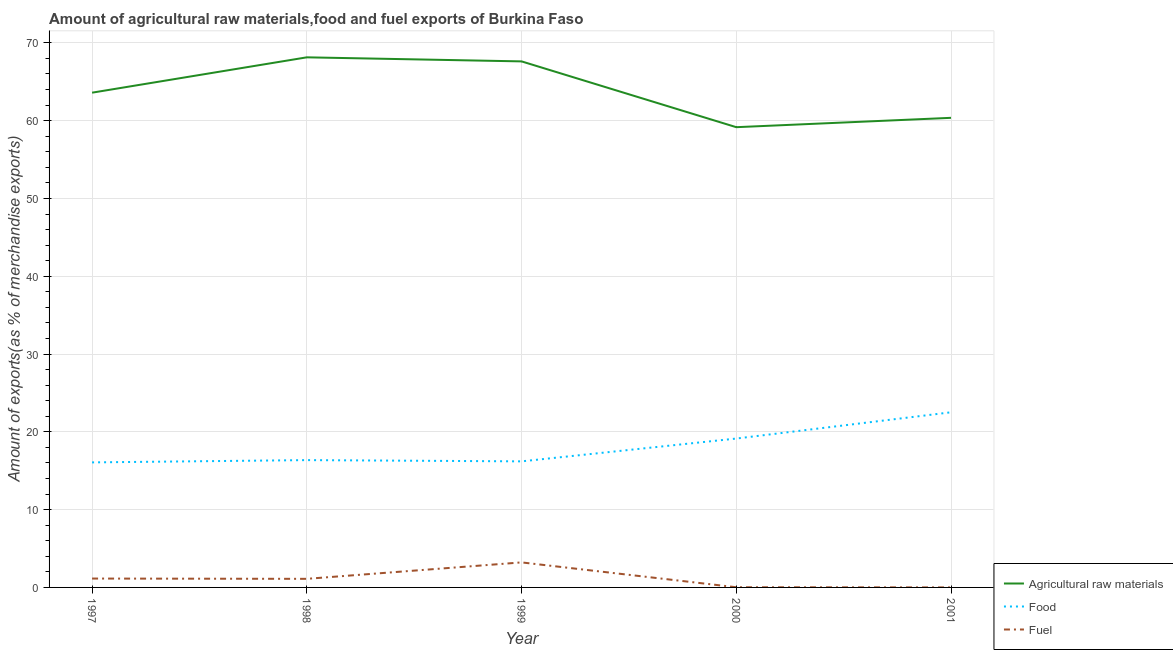What is the percentage of fuel exports in 2000?
Provide a succinct answer. 0.02. Across all years, what is the maximum percentage of fuel exports?
Offer a very short reply. 3.22. Across all years, what is the minimum percentage of food exports?
Provide a short and direct response. 16.07. In which year was the percentage of food exports maximum?
Your answer should be very brief. 2001. What is the total percentage of food exports in the graph?
Your response must be concise. 90.3. What is the difference between the percentage of fuel exports in 1998 and that in 2001?
Offer a very short reply. 1.1. What is the difference between the percentage of fuel exports in 1999 and the percentage of raw materials exports in 1998?
Make the answer very short. -64.92. What is the average percentage of food exports per year?
Offer a very short reply. 18.06. In the year 1997, what is the difference between the percentage of fuel exports and percentage of raw materials exports?
Your response must be concise. -62.46. What is the ratio of the percentage of food exports in 1998 to that in 2000?
Keep it short and to the point. 0.86. What is the difference between the highest and the second highest percentage of food exports?
Keep it short and to the point. 3.37. What is the difference between the highest and the lowest percentage of food exports?
Your response must be concise. 6.44. In how many years, is the percentage of food exports greater than the average percentage of food exports taken over all years?
Provide a succinct answer. 2. Is it the case that in every year, the sum of the percentage of raw materials exports and percentage of food exports is greater than the percentage of fuel exports?
Make the answer very short. Yes. Does the percentage of fuel exports monotonically increase over the years?
Your answer should be very brief. No. Is the percentage of fuel exports strictly greater than the percentage of food exports over the years?
Offer a terse response. No. What is the difference between two consecutive major ticks on the Y-axis?
Your response must be concise. 10. Does the graph contain grids?
Your answer should be very brief. Yes. Where does the legend appear in the graph?
Give a very brief answer. Bottom right. How many legend labels are there?
Provide a succinct answer. 3. What is the title of the graph?
Provide a succinct answer. Amount of agricultural raw materials,food and fuel exports of Burkina Faso. Does "Taxes on income" appear as one of the legend labels in the graph?
Give a very brief answer. No. What is the label or title of the X-axis?
Provide a short and direct response. Year. What is the label or title of the Y-axis?
Offer a very short reply. Amount of exports(as % of merchandise exports). What is the Amount of exports(as % of merchandise exports) in Agricultural raw materials in 1997?
Make the answer very short. 63.6. What is the Amount of exports(as % of merchandise exports) of Food in 1997?
Make the answer very short. 16.07. What is the Amount of exports(as % of merchandise exports) of Fuel in 1997?
Keep it short and to the point. 1.14. What is the Amount of exports(as % of merchandise exports) of Agricultural raw materials in 1998?
Provide a short and direct response. 68.14. What is the Amount of exports(as % of merchandise exports) of Food in 1998?
Offer a very short reply. 16.37. What is the Amount of exports(as % of merchandise exports) of Fuel in 1998?
Keep it short and to the point. 1.1. What is the Amount of exports(as % of merchandise exports) of Agricultural raw materials in 1999?
Provide a short and direct response. 67.62. What is the Amount of exports(as % of merchandise exports) of Food in 1999?
Make the answer very short. 16.2. What is the Amount of exports(as % of merchandise exports) in Fuel in 1999?
Your response must be concise. 3.22. What is the Amount of exports(as % of merchandise exports) of Agricultural raw materials in 2000?
Offer a terse response. 59.16. What is the Amount of exports(as % of merchandise exports) of Food in 2000?
Offer a very short reply. 19.14. What is the Amount of exports(as % of merchandise exports) of Fuel in 2000?
Give a very brief answer. 0.02. What is the Amount of exports(as % of merchandise exports) in Agricultural raw materials in 2001?
Make the answer very short. 60.36. What is the Amount of exports(as % of merchandise exports) of Food in 2001?
Give a very brief answer. 22.51. What is the Amount of exports(as % of merchandise exports) in Fuel in 2001?
Provide a short and direct response. 0. Across all years, what is the maximum Amount of exports(as % of merchandise exports) in Agricultural raw materials?
Offer a very short reply. 68.14. Across all years, what is the maximum Amount of exports(as % of merchandise exports) in Food?
Give a very brief answer. 22.51. Across all years, what is the maximum Amount of exports(as % of merchandise exports) of Fuel?
Your answer should be compact. 3.22. Across all years, what is the minimum Amount of exports(as % of merchandise exports) of Agricultural raw materials?
Your answer should be very brief. 59.16. Across all years, what is the minimum Amount of exports(as % of merchandise exports) of Food?
Offer a very short reply. 16.07. Across all years, what is the minimum Amount of exports(as % of merchandise exports) in Fuel?
Keep it short and to the point. 0. What is the total Amount of exports(as % of merchandise exports) in Agricultural raw materials in the graph?
Ensure brevity in your answer.  318.89. What is the total Amount of exports(as % of merchandise exports) of Food in the graph?
Your answer should be very brief. 90.3. What is the total Amount of exports(as % of merchandise exports) of Fuel in the graph?
Provide a short and direct response. 5.49. What is the difference between the Amount of exports(as % of merchandise exports) in Agricultural raw materials in 1997 and that in 1998?
Make the answer very short. -4.54. What is the difference between the Amount of exports(as % of merchandise exports) of Food in 1997 and that in 1998?
Provide a succinct answer. -0.29. What is the difference between the Amount of exports(as % of merchandise exports) in Fuel in 1997 and that in 1998?
Offer a very short reply. 0.04. What is the difference between the Amount of exports(as % of merchandise exports) of Agricultural raw materials in 1997 and that in 1999?
Provide a succinct answer. -4.02. What is the difference between the Amount of exports(as % of merchandise exports) of Food in 1997 and that in 1999?
Your answer should be compact. -0.13. What is the difference between the Amount of exports(as % of merchandise exports) of Fuel in 1997 and that in 1999?
Your response must be concise. -2.08. What is the difference between the Amount of exports(as % of merchandise exports) in Agricultural raw materials in 1997 and that in 2000?
Your answer should be very brief. 4.44. What is the difference between the Amount of exports(as % of merchandise exports) in Food in 1997 and that in 2000?
Keep it short and to the point. -3.07. What is the difference between the Amount of exports(as % of merchandise exports) of Fuel in 1997 and that in 2000?
Provide a short and direct response. 1.12. What is the difference between the Amount of exports(as % of merchandise exports) in Agricultural raw materials in 1997 and that in 2001?
Give a very brief answer. 3.23. What is the difference between the Amount of exports(as % of merchandise exports) in Food in 1997 and that in 2001?
Your answer should be compact. -6.44. What is the difference between the Amount of exports(as % of merchandise exports) of Fuel in 1997 and that in 2001?
Your response must be concise. 1.14. What is the difference between the Amount of exports(as % of merchandise exports) of Agricultural raw materials in 1998 and that in 1999?
Your answer should be compact. 0.52. What is the difference between the Amount of exports(as % of merchandise exports) in Food in 1998 and that in 1999?
Give a very brief answer. 0.16. What is the difference between the Amount of exports(as % of merchandise exports) in Fuel in 1998 and that in 1999?
Keep it short and to the point. -2.11. What is the difference between the Amount of exports(as % of merchandise exports) of Agricultural raw materials in 1998 and that in 2000?
Your answer should be very brief. 8.98. What is the difference between the Amount of exports(as % of merchandise exports) of Food in 1998 and that in 2000?
Offer a terse response. -2.77. What is the difference between the Amount of exports(as % of merchandise exports) of Fuel in 1998 and that in 2000?
Keep it short and to the point. 1.08. What is the difference between the Amount of exports(as % of merchandise exports) in Agricultural raw materials in 1998 and that in 2001?
Make the answer very short. 7.78. What is the difference between the Amount of exports(as % of merchandise exports) in Food in 1998 and that in 2001?
Provide a succinct answer. -6.15. What is the difference between the Amount of exports(as % of merchandise exports) in Fuel in 1998 and that in 2001?
Your answer should be very brief. 1.1. What is the difference between the Amount of exports(as % of merchandise exports) of Agricultural raw materials in 1999 and that in 2000?
Your answer should be compact. 8.46. What is the difference between the Amount of exports(as % of merchandise exports) in Food in 1999 and that in 2000?
Give a very brief answer. -2.93. What is the difference between the Amount of exports(as % of merchandise exports) in Fuel in 1999 and that in 2000?
Make the answer very short. 3.19. What is the difference between the Amount of exports(as % of merchandise exports) in Agricultural raw materials in 1999 and that in 2001?
Give a very brief answer. 7.26. What is the difference between the Amount of exports(as % of merchandise exports) in Food in 1999 and that in 2001?
Provide a succinct answer. -6.31. What is the difference between the Amount of exports(as % of merchandise exports) in Fuel in 1999 and that in 2001?
Your response must be concise. 3.22. What is the difference between the Amount of exports(as % of merchandise exports) of Agricultural raw materials in 2000 and that in 2001?
Keep it short and to the point. -1.2. What is the difference between the Amount of exports(as % of merchandise exports) of Food in 2000 and that in 2001?
Your answer should be very brief. -3.37. What is the difference between the Amount of exports(as % of merchandise exports) in Fuel in 2000 and that in 2001?
Offer a very short reply. 0.02. What is the difference between the Amount of exports(as % of merchandise exports) in Agricultural raw materials in 1997 and the Amount of exports(as % of merchandise exports) in Food in 1998?
Your response must be concise. 47.23. What is the difference between the Amount of exports(as % of merchandise exports) in Agricultural raw materials in 1997 and the Amount of exports(as % of merchandise exports) in Fuel in 1998?
Your answer should be compact. 62.49. What is the difference between the Amount of exports(as % of merchandise exports) in Food in 1997 and the Amount of exports(as % of merchandise exports) in Fuel in 1998?
Provide a succinct answer. 14.97. What is the difference between the Amount of exports(as % of merchandise exports) of Agricultural raw materials in 1997 and the Amount of exports(as % of merchandise exports) of Food in 1999?
Keep it short and to the point. 47.39. What is the difference between the Amount of exports(as % of merchandise exports) in Agricultural raw materials in 1997 and the Amount of exports(as % of merchandise exports) in Fuel in 1999?
Offer a very short reply. 60.38. What is the difference between the Amount of exports(as % of merchandise exports) in Food in 1997 and the Amount of exports(as % of merchandise exports) in Fuel in 1999?
Your answer should be very brief. 12.86. What is the difference between the Amount of exports(as % of merchandise exports) in Agricultural raw materials in 1997 and the Amount of exports(as % of merchandise exports) in Food in 2000?
Provide a short and direct response. 44.46. What is the difference between the Amount of exports(as % of merchandise exports) in Agricultural raw materials in 1997 and the Amount of exports(as % of merchandise exports) in Fuel in 2000?
Provide a succinct answer. 63.58. What is the difference between the Amount of exports(as % of merchandise exports) in Food in 1997 and the Amount of exports(as % of merchandise exports) in Fuel in 2000?
Provide a short and direct response. 16.05. What is the difference between the Amount of exports(as % of merchandise exports) in Agricultural raw materials in 1997 and the Amount of exports(as % of merchandise exports) in Food in 2001?
Make the answer very short. 41.09. What is the difference between the Amount of exports(as % of merchandise exports) of Agricultural raw materials in 1997 and the Amount of exports(as % of merchandise exports) of Fuel in 2001?
Keep it short and to the point. 63.6. What is the difference between the Amount of exports(as % of merchandise exports) of Food in 1997 and the Amount of exports(as % of merchandise exports) of Fuel in 2001?
Your answer should be compact. 16.07. What is the difference between the Amount of exports(as % of merchandise exports) in Agricultural raw materials in 1998 and the Amount of exports(as % of merchandise exports) in Food in 1999?
Provide a short and direct response. 51.94. What is the difference between the Amount of exports(as % of merchandise exports) of Agricultural raw materials in 1998 and the Amount of exports(as % of merchandise exports) of Fuel in 1999?
Give a very brief answer. 64.92. What is the difference between the Amount of exports(as % of merchandise exports) of Food in 1998 and the Amount of exports(as % of merchandise exports) of Fuel in 1999?
Keep it short and to the point. 13.15. What is the difference between the Amount of exports(as % of merchandise exports) of Agricultural raw materials in 1998 and the Amount of exports(as % of merchandise exports) of Food in 2000?
Provide a short and direct response. 49. What is the difference between the Amount of exports(as % of merchandise exports) in Agricultural raw materials in 1998 and the Amount of exports(as % of merchandise exports) in Fuel in 2000?
Provide a short and direct response. 68.12. What is the difference between the Amount of exports(as % of merchandise exports) in Food in 1998 and the Amount of exports(as % of merchandise exports) in Fuel in 2000?
Provide a short and direct response. 16.34. What is the difference between the Amount of exports(as % of merchandise exports) in Agricultural raw materials in 1998 and the Amount of exports(as % of merchandise exports) in Food in 2001?
Offer a very short reply. 45.63. What is the difference between the Amount of exports(as % of merchandise exports) of Agricultural raw materials in 1998 and the Amount of exports(as % of merchandise exports) of Fuel in 2001?
Your answer should be very brief. 68.14. What is the difference between the Amount of exports(as % of merchandise exports) in Food in 1998 and the Amount of exports(as % of merchandise exports) in Fuel in 2001?
Provide a short and direct response. 16.36. What is the difference between the Amount of exports(as % of merchandise exports) of Agricultural raw materials in 1999 and the Amount of exports(as % of merchandise exports) of Food in 2000?
Your answer should be compact. 48.48. What is the difference between the Amount of exports(as % of merchandise exports) of Agricultural raw materials in 1999 and the Amount of exports(as % of merchandise exports) of Fuel in 2000?
Give a very brief answer. 67.6. What is the difference between the Amount of exports(as % of merchandise exports) in Food in 1999 and the Amount of exports(as % of merchandise exports) in Fuel in 2000?
Your answer should be compact. 16.18. What is the difference between the Amount of exports(as % of merchandise exports) of Agricultural raw materials in 1999 and the Amount of exports(as % of merchandise exports) of Food in 2001?
Your answer should be very brief. 45.11. What is the difference between the Amount of exports(as % of merchandise exports) in Agricultural raw materials in 1999 and the Amount of exports(as % of merchandise exports) in Fuel in 2001?
Offer a terse response. 67.62. What is the difference between the Amount of exports(as % of merchandise exports) of Food in 1999 and the Amount of exports(as % of merchandise exports) of Fuel in 2001?
Ensure brevity in your answer.  16.2. What is the difference between the Amount of exports(as % of merchandise exports) in Agricultural raw materials in 2000 and the Amount of exports(as % of merchandise exports) in Food in 2001?
Keep it short and to the point. 36.65. What is the difference between the Amount of exports(as % of merchandise exports) in Agricultural raw materials in 2000 and the Amount of exports(as % of merchandise exports) in Fuel in 2001?
Your answer should be compact. 59.16. What is the difference between the Amount of exports(as % of merchandise exports) of Food in 2000 and the Amount of exports(as % of merchandise exports) of Fuel in 2001?
Your response must be concise. 19.14. What is the average Amount of exports(as % of merchandise exports) in Agricultural raw materials per year?
Keep it short and to the point. 63.78. What is the average Amount of exports(as % of merchandise exports) in Food per year?
Give a very brief answer. 18.06. What is the average Amount of exports(as % of merchandise exports) of Fuel per year?
Your answer should be very brief. 1.1. In the year 1997, what is the difference between the Amount of exports(as % of merchandise exports) in Agricultural raw materials and Amount of exports(as % of merchandise exports) in Food?
Provide a succinct answer. 47.53. In the year 1997, what is the difference between the Amount of exports(as % of merchandise exports) in Agricultural raw materials and Amount of exports(as % of merchandise exports) in Fuel?
Ensure brevity in your answer.  62.46. In the year 1997, what is the difference between the Amount of exports(as % of merchandise exports) in Food and Amount of exports(as % of merchandise exports) in Fuel?
Your response must be concise. 14.93. In the year 1998, what is the difference between the Amount of exports(as % of merchandise exports) of Agricultural raw materials and Amount of exports(as % of merchandise exports) of Food?
Your response must be concise. 51.78. In the year 1998, what is the difference between the Amount of exports(as % of merchandise exports) in Agricultural raw materials and Amount of exports(as % of merchandise exports) in Fuel?
Offer a terse response. 67.04. In the year 1998, what is the difference between the Amount of exports(as % of merchandise exports) of Food and Amount of exports(as % of merchandise exports) of Fuel?
Offer a terse response. 15.26. In the year 1999, what is the difference between the Amount of exports(as % of merchandise exports) of Agricultural raw materials and Amount of exports(as % of merchandise exports) of Food?
Keep it short and to the point. 51.42. In the year 1999, what is the difference between the Amount of exports(as % of merchandise exports) of Agricultural raw materials and Amount of exports(as % of merchandise exports) of Fuel?
Provide a short and direct response. 64.4. In the year 1999, what is the difference between the Amount of exports(as % of merchandise exports) in Food and Amount of exports(as % of merchandise exports) in Fuel?
Provide a short and direct response. 12.99. In the year 2000, what is the difference between the Amount of exports(as % of merchandise exports) of Agricultural raw materials and Amount of exports(as % of merchandise exports) of Food?
Make the answer very short. 40.02. In the year 2000, what is the difference between the Amount of exports(as % of merchandise exports) in Agricultural raw materials and Amount of exports(as % of merchandise exports) in Fuel?
Your response must be concise. 59.14. In the year 2000, what is the difference between the Amount of exports(as % of merchandise exports) in Food and Amount of exports(as % of merchandise exports) in Fuel?
Your answer should be compact. 19.12. In the year 2001, what is the difference between the Amount of exports(as % of merchandise exports) of Agricultural raw materials and Amount of exports(as % of merchandise exports) of Food?
Offer a very short reply. 37.85. In the year 2001, what is the difference between the Amount of exports(as % of merchandise exports) in Agricultural raw materials and Amount of exports(as % of merchandise exports) in Fuel?
Offer a very short reply. 60.36. In the year 2001, what is the difference between the Amount of exports(as % of merchandise exports) of Food and Amount of exports(as % of merchandise exports) of Fuel?
Offer a terse response. 22.51. What is the ratio of the Amount of exports(as % of merchandise exports) in Agricultural raw materials in 1997 to that in 1998?
Offer a very short reply. 0.93. What is the ratio of the Amount of exports(as % of merchandise exports) of Food in 1997 to that in 1998?
Offer a very short reply. 0.98. What is the ratio of the Amount of exports(as % of merchandise exports) in Fuel in 1997 to that in 1998?
Provide a succinct answer. 1.03. What is the ratio of the Amount of exports(as % of merchandise exports) of Agricultural raw materials in 1997 to that in 1999?
Offer a very short reply. 0.94. What is the ratio of the Amount of exports(as % of merchandise exports) of Food in 1997 to that in 1999?
Make the answer very short. 0.99. What is the ratio of the Amount of exports(as % of merchandise exports) in Fuel in 1997 to that in 1999?
Ensure brevity in your answer.  0.35. What is the ratio of the Amount of exports(as % of merchandise exports) in Agricultural raw materials in 1997 to that in 2000?
Your answer should be very brief. 1.07. What is the ratio of the Amount of exports(as % of merchandise exports) of Food in 1997 to that in 2000?
Keep it short and to the point. 0.84. What is the ratio of the Amount of exports(as % of merchandise exports) in Fuel in 1997 to that in 2000?
Your answer should be compact. 49.36. What is the ratio of the Amount of exports(as % of merchandise exports) in Agricultural raw materials in 1997 to that in 2001?
Your response must be concise. 1.05. What is the ratio of the Amount of exports(as % of merchandise exports) of Food in 1997 to that in 2001?
Give a very brief answer. 0.71. What is the ratio of the Amount of exports(as % of merchandise exports) of Fuel in 1997 to that in 2001?
Provide a short and direct response. 404.75. What is the ratio of the Amount of exports(as % of merchandise exports) in Agricultural raw materials in 1998 to that in 1999?
Provide a succinct answer. 1.01. What is the ratio of the Amount of exports(as % of merchandise exports) in Fuel in 1998 to that in 1999?
Ensure brevity in your answer.  0.34. What is the ratio of the Amount of exports(as % of merchandise exports) of Agricultural raw materials in 1998 to that in 2000?
Offer a terse response. 1.15. What is the ratio of the Amount of exports(as % of merchandise exports) of Food in 1998 to that in 2000?
Provide a succinct answer. 0.86. What is the ratio of the Amount of exports(as % of merchandise exports) in Fuel in 1998 to that in 2000?
Provide a succinct answer. 47.79. What is the ratio of the Amount of exports(as % of merchandise exports) of Agricultural raw materials in 1998 to that in 2001?
Give a very brief answer. 1.13. What is the ratio of the Amount of exports(as % of merchandise exports) of Food in 1998 to that in 2001?
Offer a very short reply. 0.73. What is the ratio of the Amount of exports(as % of merchandise exports) of Fuel in 1998 to that in 2001?
Your answer should be compact. 391.84. What is the ratio of the Amount of exports(as % of merchandise exports) in Agricultural raw materials in 1999 to that in 2000?
Offer a very short reply. 1.14. What is the ratio of the Amount of exports(as % of merchandise exports) in Food in 1999 to that in 2000?
Your response must be concise. 0.85. What is the ratio of the Amount of exports(as % of merchandise exports) in Fuel in 1999 to that in 2000?
Provide a short and direct response. 139.25. What is the ratio of the Amount of exports(as % of merchandise exports) of Agricultural raw materials in 1999 to that in 2001?
Give a very brief answer. 1.12. What is the ratio of the Amount of exports(as % of merchandise exports) of Food in 1999 to that in 2001?
Provide a short and direct response. 0.72. What is the ratio of the Amount of exports(as % of merchandise exports) of Fuel in 1999 to that in 2001?
Give a very brief answer. 1141.77. What is the ratio of the Amount of exports(as % of merchandise exports) of Agricultural raw materials in 2000 to that in 2001?
Your answer should be compact. 0.98. What is the ratio of the Amount of exports(as % of merchandise exports) of Food in 2000 to that in 2001?
Offer a terse response. 0.85. What is the ratio of the Amount of exports(as % of merchandise exports) of Fuel in 2000 to that in 2001?
Your answer should be compact. 8.2. What is the difference between the highest and the second highest Amount of exports(as % of merchandise exports) in Agricultural raw materials?
Your answer should be compact. 0.52. What is the difference between the highest and the second highest Amount of exports(as % of merchandise exports) in Food?
Keep it short and to the point. 3.37. What is the difference between the highest and the second highest Amount of exports(as % of merchandise exports) in Fuel?
Your answer should be compact. 2.08. What is the difference between the highest and the lowest Amount of exports(as % of merchandise exports) of Agricultural raw materials?
Provide a short and direct response. 8.98. What is the difference between the highest and the lowest Amount of exports(as % of merchandise exports) in Food?
Give a very brief answer. 6.44. What is the difference between the highest and the lowest Amount of exports(as % of merchandise exports) in Fuel?
Your answer should be very brief. 3.22. 